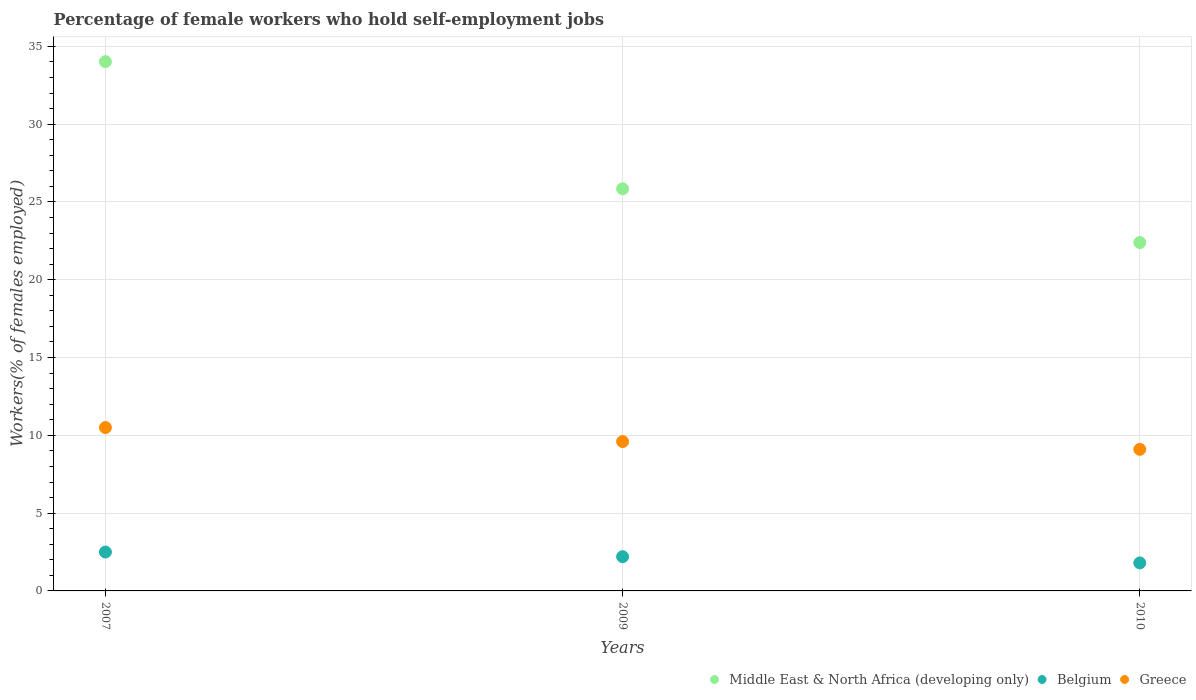Is the number of dotlines equal to the number of legend labels?
Make the answer very short. Yes. What is the percentage of self-employed female workers in Middle East & North Africa (developing only) in 2010?
Give a very brief answer. 22.39. Across all years, what is the maximum percentage of self-employed female workers in Belgium?
Ensure brevity in your answer.  2.5. Across all years, what is the minimum percentage of self-employed female workers in Greece?
Provide a short and direct response. 9.1. In which year was the percentage of self-employed female workers in Greece maximum?
Offer a very short reply. 2007. What is the total percentage of self-employed female workers in Middle East & North Africa (developing only) in the graph?
Provide a short and direct response. 82.26. What is the difference between the percentage of self-employed female workers in Greece in 2007 and that in 2009?
Provide a succinct answer. 0.9. What is the difference between the percentage of self-employed female workers in Belgium in 2010 and the percentage of self-employed female workers in Middle East & North Africa (developing only) in 2007?
Provide a succinct answer. -32.22. What is the average percentage of self-employed female workers in Middle East & North Africa (developing only) per year?
Your response must be concise. 27.42. In the year 2009, what is the difference between the percentage of self-employed female workers in Belgium and percentage of self-employed female workers in Greece?
Offer a terse response. -7.4. What is the ratio of the percentage of self-employed female workers in Greece in 2009 to that in 2010?
Your answer should be very brief. 1.05. Is the difference between the percentage of self-employed female workers in Belgium in 2009 and 2010 greater than the difference between the percentage of self-employed female workers in Greece in 2009 and 2010?
Make the answer very short. No. What is the difference between the highest and the second highest percentage of self-employed female workers in Middle East & North Africa (developing only)?
Your answer should be very brief. 8.17. What is the difference between the highest and the lowest percentage of self-employed female workers in Greece?
Your answer should be compact. 1.4. Is it the case that in every year, the sum of the percentage of self-employed female workers in Belgium and percentage of self-employed female workers in Middle East & North Africa (developing only)  is greater than the percentage of self-employed female workers in Greece?
Your response must be concise. Yes. Does the percentage of self-employed female workers in Greece monotonically increase over the years?
Offer a terse response. No. What is the difference between two consecutive major ticks on the Y-axis?
Your answer should be very brief. 5. Are the values on the major ticks of Y-axis written in scientific E-notation?
Ensure brevity in your answer.  No. Does the graph contain any zero values?
Make the answer very short. No. Does the graph contain grids?
Your answer should be very brief. Yes. How many legend labels are there?
Provide a succinct answer. 3. How are the legend labels stacked?
Provide a short and direct response. Horizontal. What is the title of the graph?
Keep it short and to the point. Percentage of female workers who hold self-employment jobs. What is the label or title of the X-axis?
Give a very brief answer. Years. What is the label or title of the Y-axis?
Keep it short and to the point. Workers(% of females employed). What is the Workers(% of females employed) of Middle East & North Africa (developing only) in 2007?
Offer a very short reply. 34.02. What is the Workers(% of females employed) of Middle East & North Africa (developing only) in 2009?
Make the answer very short. 25.85. What is the Workers(% of females employed) in Belgium in 2009?
Keep it short and to the point. 2.2. What is the Workers(% of females employed) of Greece in 2009?
Offer a terse response. 9.6. What is the Workers(% of females employed) in Middle East & North Africa (developing only) in 2010?
Make the answer very short. 22.39. What is the Workers(% of females employed) in Belgium in 2010?
Ensure brevity in your answer.  1.8. What is the Workers(% of females employed) in Greece in 2010?
Provide a short and direct response. 9.1. Across all years, what is the maximum Workers(% of females employed) in Middle East & North Africa (developing only)?
Your response must be concise. 34.02. Across all years, what is the minimum Workers(% of females employed) of Middle East & North Africa (developing only)?
Provide a succinct answer. 22.39. Across all years, what is the minimum Workers(% of females employed) of Belgium?
Make the answer very short. 1.8. Across all years, what is the minimum Workers(% of females employed) in Greece?
Ensure brevity in your answer.  9.1. What is the total Workers(% of females employed) in Middle East & North Africa (developing only) in the graph?
Offer a terse response. 82.26. What is the total Workers(% of females employed) of Greece in the graph?
Your answer should be very brief. 29.2. What is the difference between the Workers(% of females employed) in Middle East & North Africa (developing only) in 2007 and that in 2009?
Offer a very short reply. 8.17. What is the difference between the Workers(% of females employed) of Belgium in 2007 and that in 2009?
Your answer should be compact. 0.3. What is the difference between the Workers(% of females employed) in Greece in 2007 and that in 2009?
Your answer should be very brief. 0.9. What is the difference between the Workers(% of females employed) of Middle East & North Africa (developing only) in 2007 and that in 2010?
Give a very brief answer. 11.63. What is the difference between the Workers(% of females employed) of Belgium in 2007 and that in 2010?
Make the answer very short. 0.7. What is the difference between the Workers(% of females employed) of Middle East & North Africa (developing only) in 2009 and that in 2010?
Give a very brief answer. 3.45. What is the difference between the Workers(% of females employed) of Middle East & North Africa (developing only) in 2007 and the Workers(% of females employed) of Belgium in 2009?
Your response must be concise. 31.82. What is the difference between the Workers(% of females employed) in Middle East & North Africa (developing only) in 2007 and the Workers(% of females employed) in Greece in 2009?
Offer a very short reply. 24.42. What is the difference between the Workers(% of females employed) in Middle East & North Africa (developing only) in 2007 and the Workers(% of females employed) in Belgium in 2010?
Give a very brief answer. 32.22. What is the difference between the Workers(% of females employed) in Middle East & North Africa (developing only) in 2007 and the Workers(% of females employed) in Greece in 2010?
Your answer should be very brief. 24.92. What is the difference between the Workers(% of females employed) of Belgium in 2007 and the Workers(% of females employed) of Greece in 2010?
Make the answer very short. -6.6. What is the difference between the Workers(% of females employed) of Middle East & North Africa (developing only) in 2009 and the Workers(% of females employed) of Belgium in 2010?
Provide a succinct answer. 24.05. What is the difference between the Workers(% of females employed) of Middle East & North Africa (developing only) in 2009 and the Workers(% of females employed) of Greece in 2010?
Your response must be concise. 16.75. What is the difference between the Workers(% of females employed) in Belgium in 2009 and the Workers(% of females employed) in Greece in 2010?
Make the answer very short. -6.9. What is the average Workers(% of females employed) in Middle East & North Africa (developing only) per year?
Give a very brief answer. 27.42. What is the average Workers(% of females employed) of Belgium per year?
Your answer should be very brief. 2.17. What is the average Workers(% of females employed) of Greece per year?
Offer a very short reply. 9.73. In the year 2007, what is the difference between the Workers(% of females employed) of Middle East & North Africa (developing only) and Workers(% of females employed) of Belgium?
Provide a short and direct response. 31.52. In the year 2007, what is the difference between the Workers(% of females employed) in Middle East & North Africa (developing only) and Workers(% of females employed) in Greece?
Ensure brevity in your answer.  23.52. In the year 2009, what is the difference between the Workers(% of females employed) of Middle East & North Africa (developing only) and Workers(% of females employed) of Belgium?
Your answer should be very brief. 23.65. In the year 2009, what is the difference between the Workers(% of females employed) of Middle East & North Africa (developing only) and Workers(% of females employed) of Greece?
Give a very brief answer. 16.25. In the year 2010, what is the difference between the Workers(% of females employed) of Middle East & North Africa (developing only) and Workers(% of females employed) of Belgium?
Your response must be concise. 20.59. In the year 2010, what is the difference between the Workers(% of females employed) of Middle East & North Africa (developing only) and Workers(% of females employed) of Greece?
Offer a very short reply. 13.29. What is the ratio of the Workers(% of females employed) in Middle East & North Africa (developing only) in 2007 to that in 2009?
Offer a very short reply. 1.32. What is the ratio of the Workers(% of females employed) of Belgium in 2007 to that in 2009?
Make the answer very short. 1.14. What is the ratio of the Workers(% of females employed) of Greece in 2007 to that in 2009?
Offer a very short reply. 1.09. What is the ratio of the Workers(% of females employed) in Middle East & North Africa (developing only) in 2007 to that in 2010?
Offer a very short reply. 1.52. What is the ratio of the Workers(% of females employed) of Belgium in 2007 to that in 2010?
Provide a succinct answer. 1.39. What is the ratio of the Workers(% of females employed) in Greece in 2007 to that in 2010?
Your answer should be very brief. 1.15. What is the ratio of the Workers(% of females employed) of Middle East & North Africa (developing only) in 2009 to that in 2010?
Your answer should be very brief. 1.15. What is the ratio of the Workers(% of females employed) of Belgium in 2009 to that in 2010?
Ensure brevity in your answer.  1.22. What is the ratio of the Workers(% of females employed) in Greece in 2009 to that in 2010?
Ensure brevity in your answer.  1.05. What is the difference between the highest and the second highest Workers(% of females employed) of Middle East & North Africa (developing only)?
Offer a very short reply. 8.17. What is the difference between the highest and the lowest Workers(% of females employed) in Middle East & North Africa (developing only)?
Your answer should be compact. 11.63. What is the difference between the highest and the lowest Workers(% of females employed) of Belgium?
Your answer should be very brief. 0.7. What is the difference between the highest and the lowest Workers(% of females employed) in Greece?
Your answer should be very brief. 1.4. 